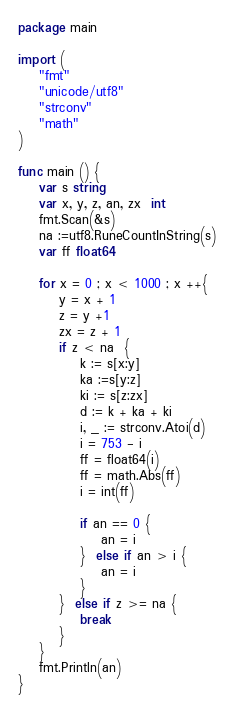Convert code to text. <code><loc_0><loc_0><loc_500><loc_500><_Go_>package main 

import (
	"fmt"
	"unicode/utf8"
	"strconv"
	"math"
)

func main () {
	var s string
	var x, y, z, an, zx  int
	fmt.Scan(&s)
	na :=utf8.RuneCountInString(s)
	var ff float64

	for x = 0 ; x < 1000 ; x ++{
		y = x + 1
		z = y +1
		zx = z + 1
		if z < na  {
			k := s[x:y]
			ka :=s[y:z]
			ki := s[z:zx]
			d := k + ka + ki
			i, _ := strconv.Atoi(d)
			i = 753 - i
			ff = float64(i) 
			ff = math.Abs(ff)
			i = int(ff)

			if an == 0 {
				an = i
			}  else if an > i {
				an = i
			}
		}  else if z >= na {
			break 
		}
	}
	fmt.Println(an)
}</code> 